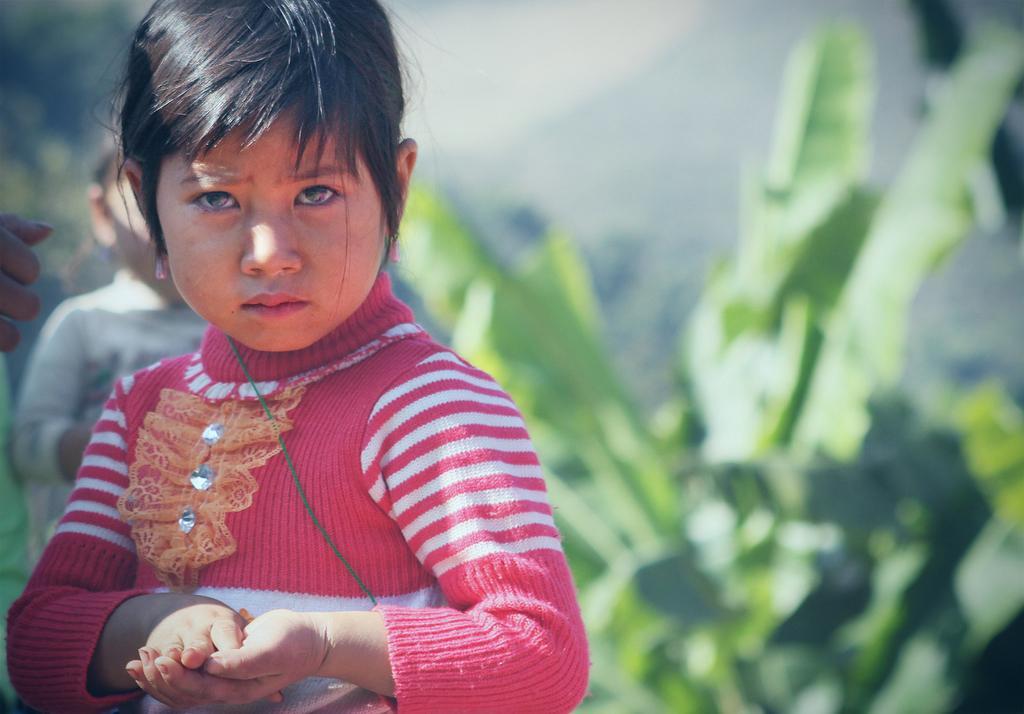Describe this image in one or two sentences. In this image, there are a few people. We can also see some plants and the blurred background. 